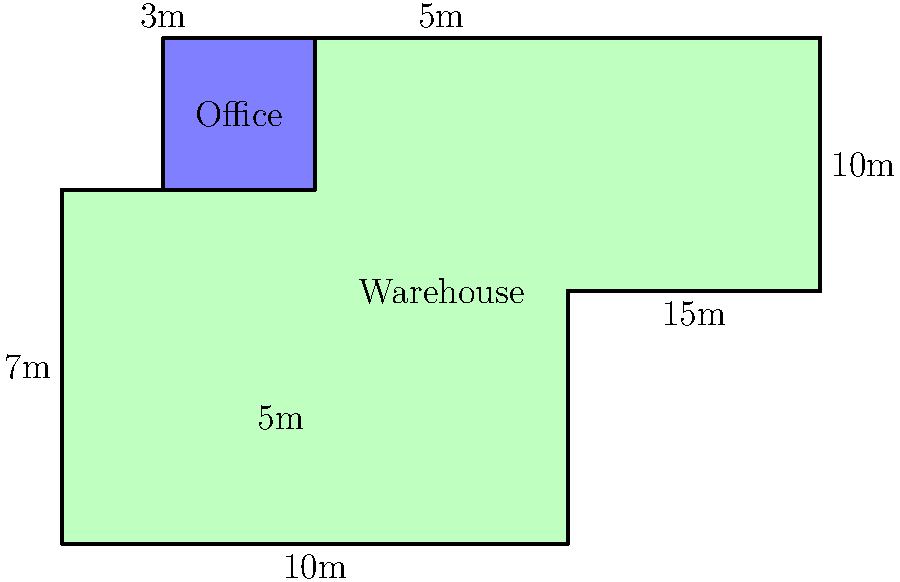As a raw material supplier, you're planning to optimize your warehouse space. The floor plan of your warehouse is shown above, with an irregularly shaped main area and a small office space. Calculate the total floor area of the warehouse, excluding the office space. All measurements are in meters. To calculate the total floor area of the warehouse excluding the office space, we need to:

1. Divide the warehouse into regular shapes
2. Calculate the area of each shape
3. Sum up the areas
4. Subtract the office area

Let's break it down:

1. The warehouse can be divided into a large rectangle and a smaller rectangle:
   - Large rectangle: 10m x 7m
   - Small rectangle: 5m x 3m

2. Calculate the areas:
   - Area of large rectangle = $10m \times 7m = 70m^2$
   - Area of small rectangle = $5m \times 3m = 15m^2$

3. Sum up the areas:
   Total area = $70m^2 + 15m^2 = 85m^2$

4. Calculate and subtract the office area:
   Office area = $3m \times 3m = 9m^2$
   
   Warehouse area excluding office = $85m^2 - 9m^2 = 76m^2$

Therefore, the total floor area of the warehouse, excluding the office space, is $76m^2$.
Answer: $76m^2$ 